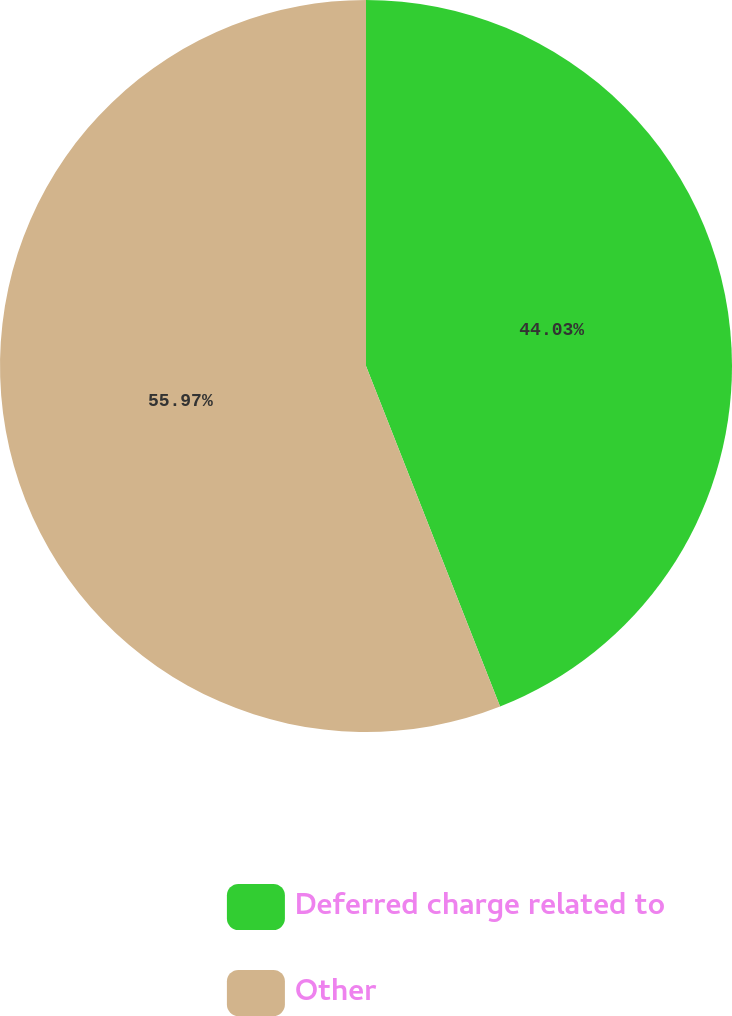Convert chart to OTSL. <chart><loc_0><loc_0><loc_500><loc_500><pie_chart><fcel>Deferred charge related to<fcel>Other<nl><fcel>44.03%<fcel>55.97%<nl></chart> 